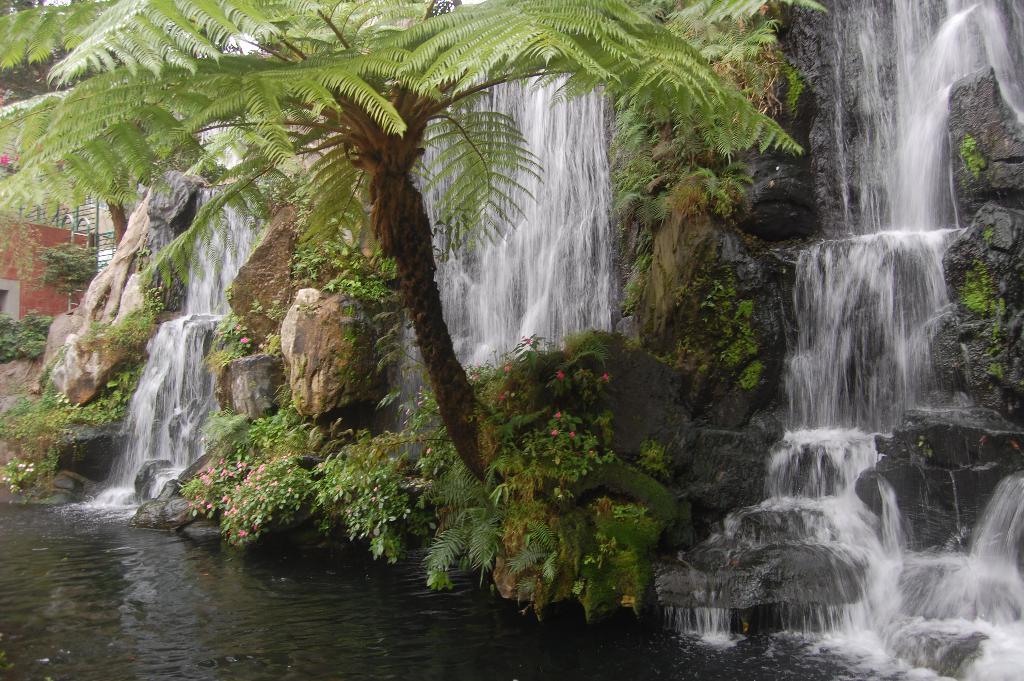How would you summarize this image in a sentence or two? In this picture we can see water falls, plants and a tree. there are some rocks. 